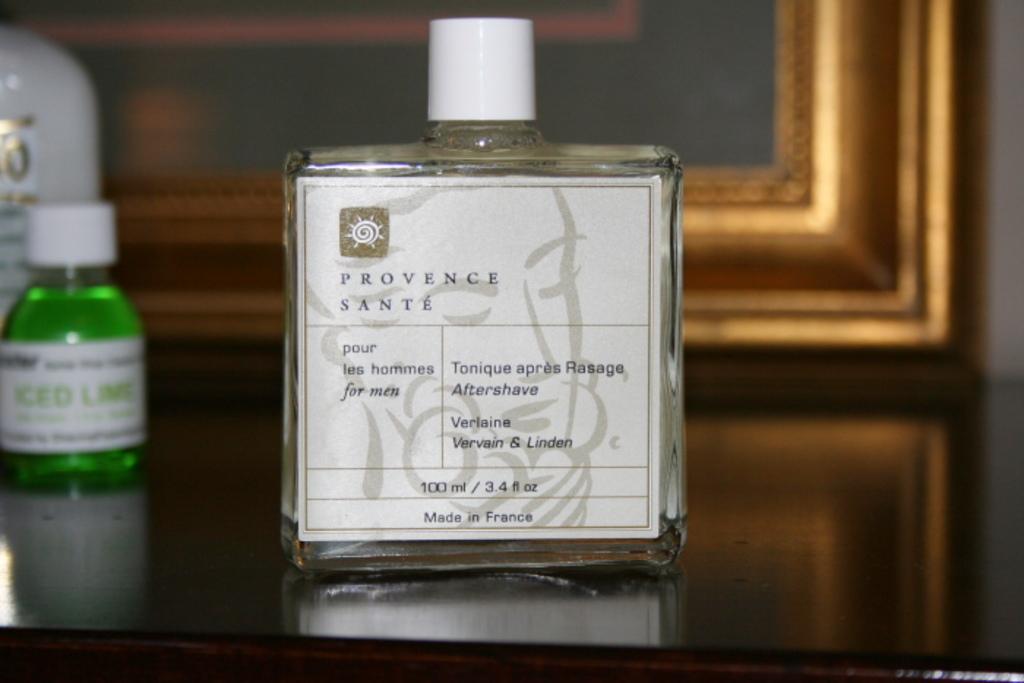What country was this made in?
Offer a very short reply. France. 